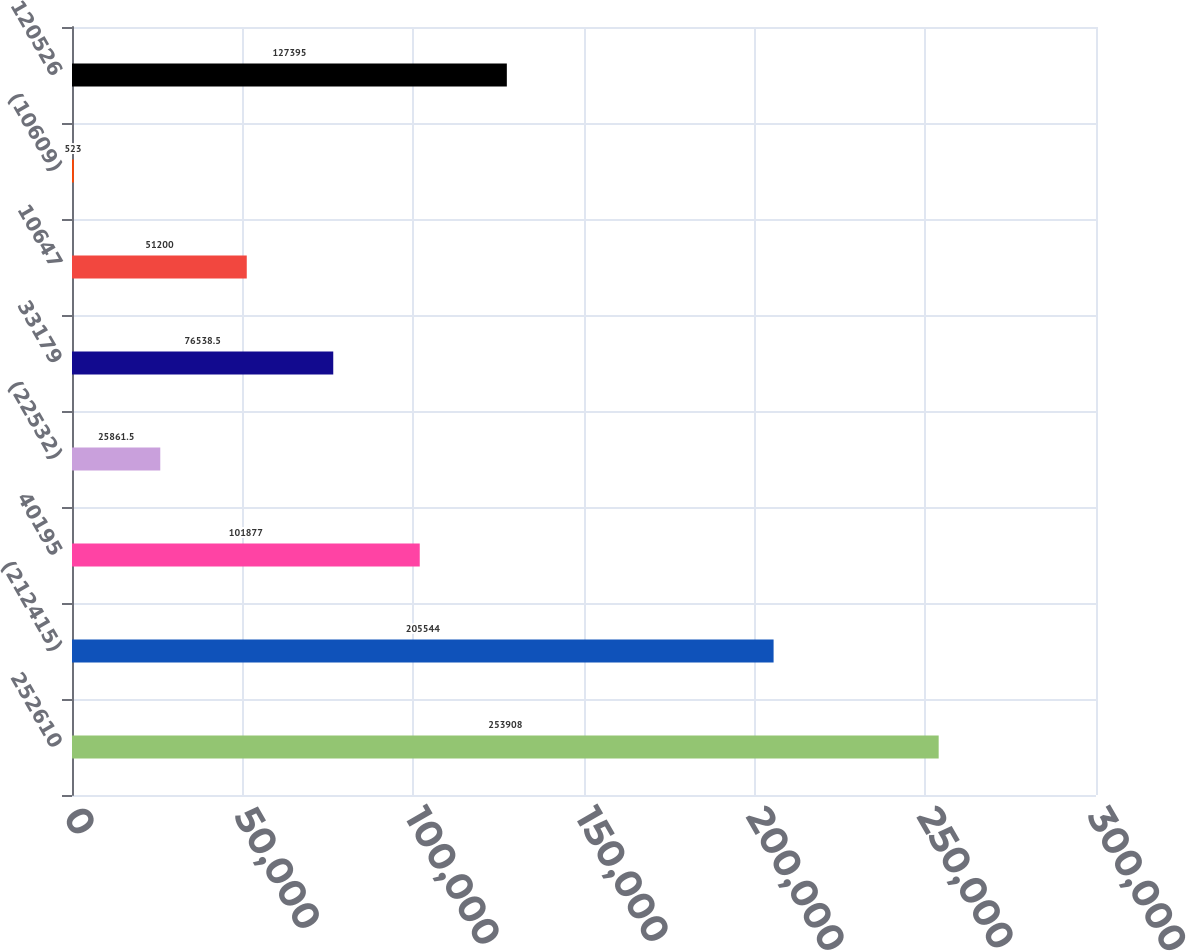Convert chart. <chart><loc_0><loc_0><loc_500><loc_500><bar_chart><fcel>252610<fcel>(212415)<fcel>40195<fcel>(22532)<fcel>33179<fcel>10647<fcel>(10609)<fcel>120526<nl><fcel>253908<fcel>205544<fcel>101877<fcel>25861.5<fcel>76538.5<fcel>51200<fcel>523<fcel>127395<nl></chart> 